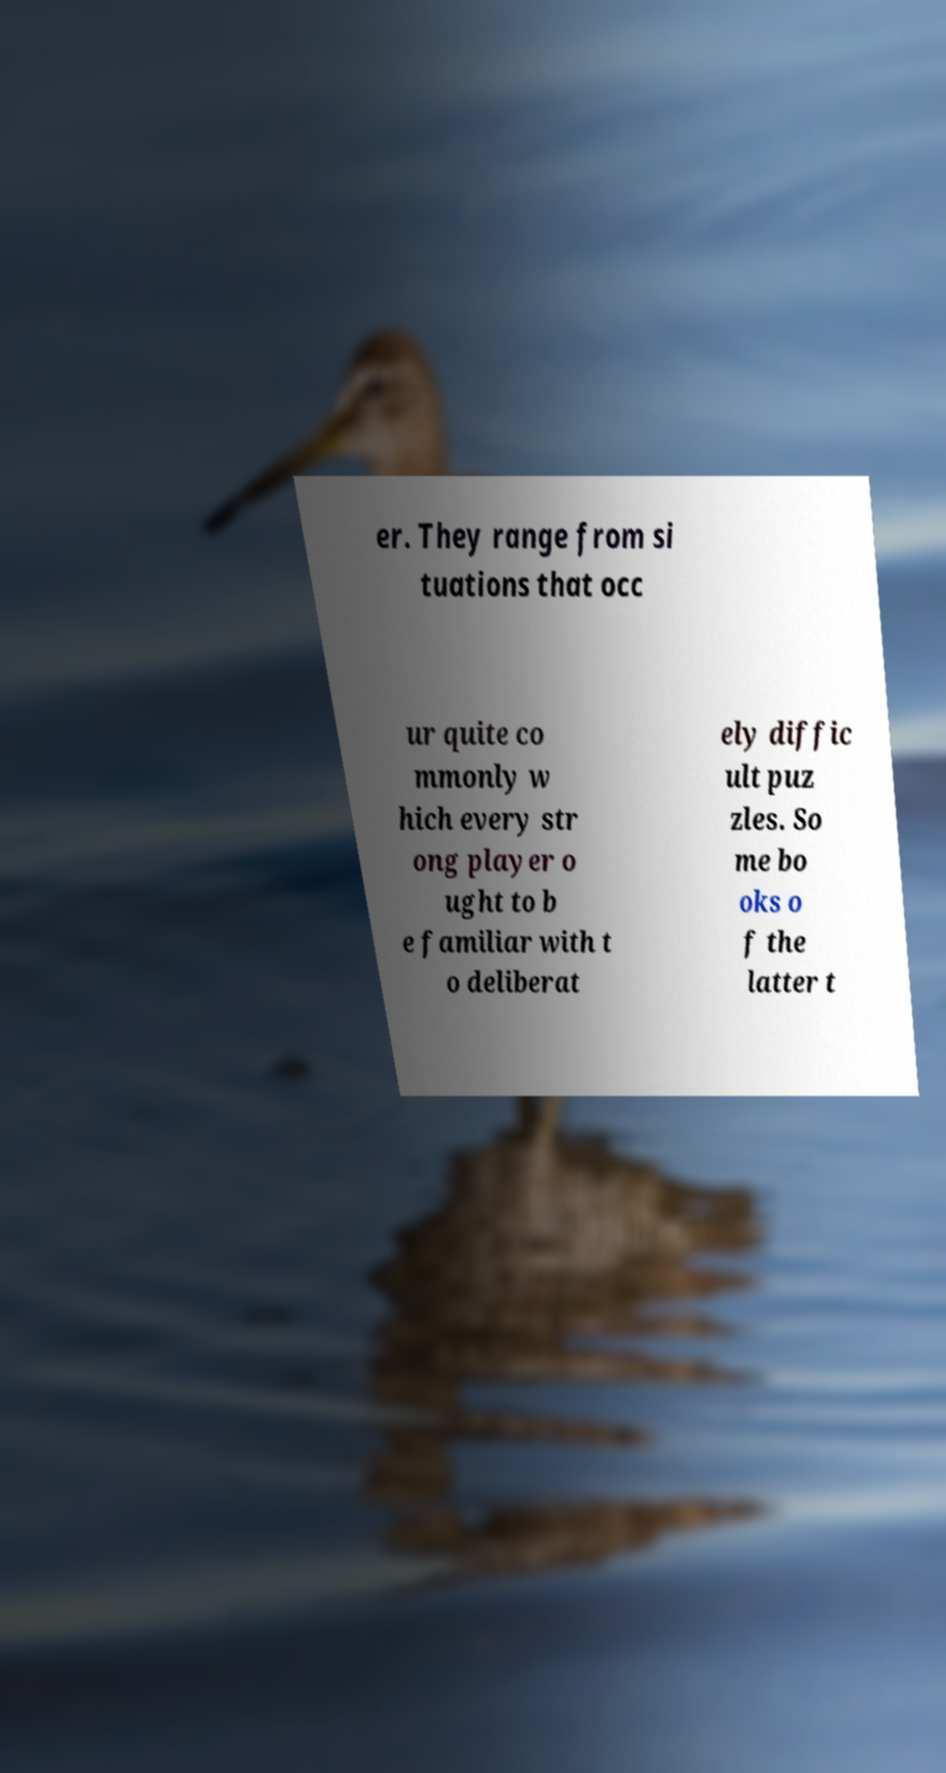Please read and relay the text visible in this image. What does it say? er. They range from si tuations that occ ur quite co mmonly w hich every str ong player o ught to b e familiar with t o deliberat ely diffic ult puz zles. So me bo oks o f the latter t 